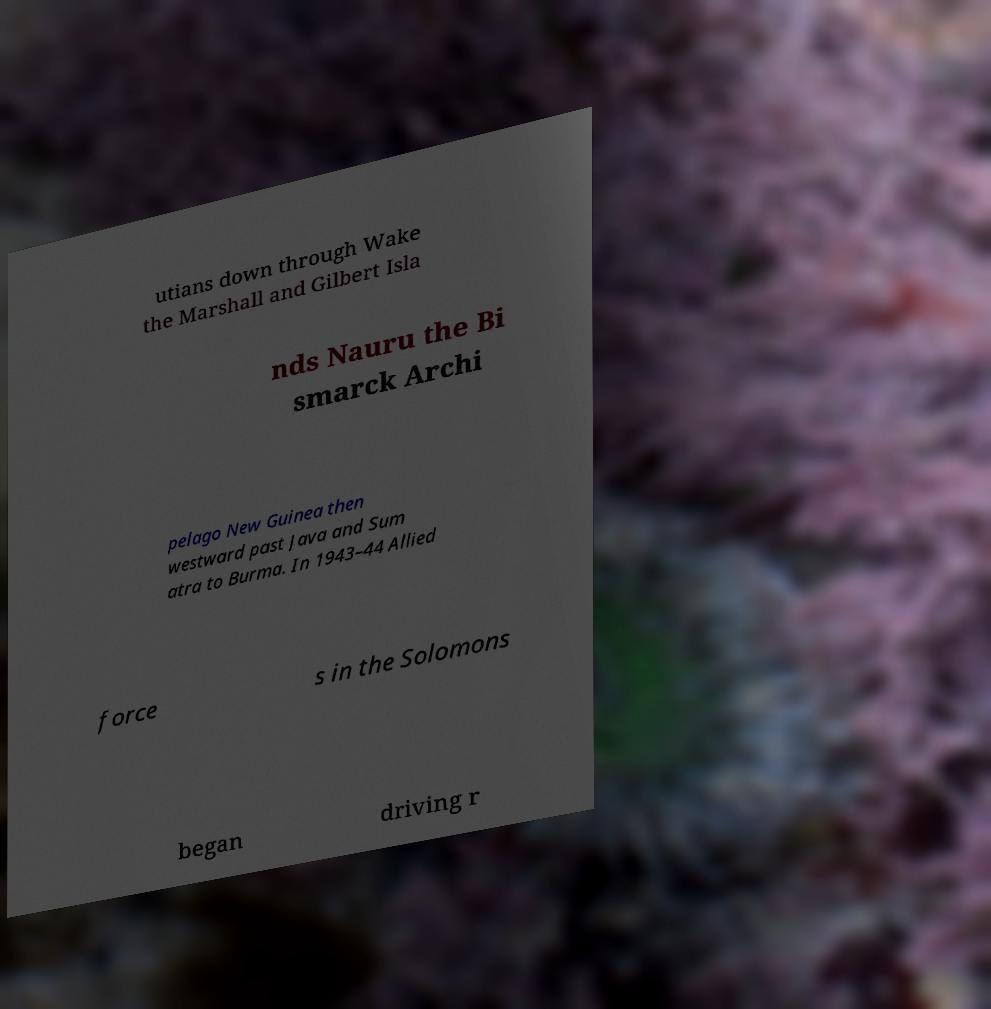What messages or text are displayed in this image? I need them in a readable, typed format. utians down through Wake the Marshall and Gilbert Isla nds Nauru the Bi smarck Archi pelago New Guinea then westward past Java and Sum atra to Burma. In 1943–44 Allied force s in the Solomons began driving r 